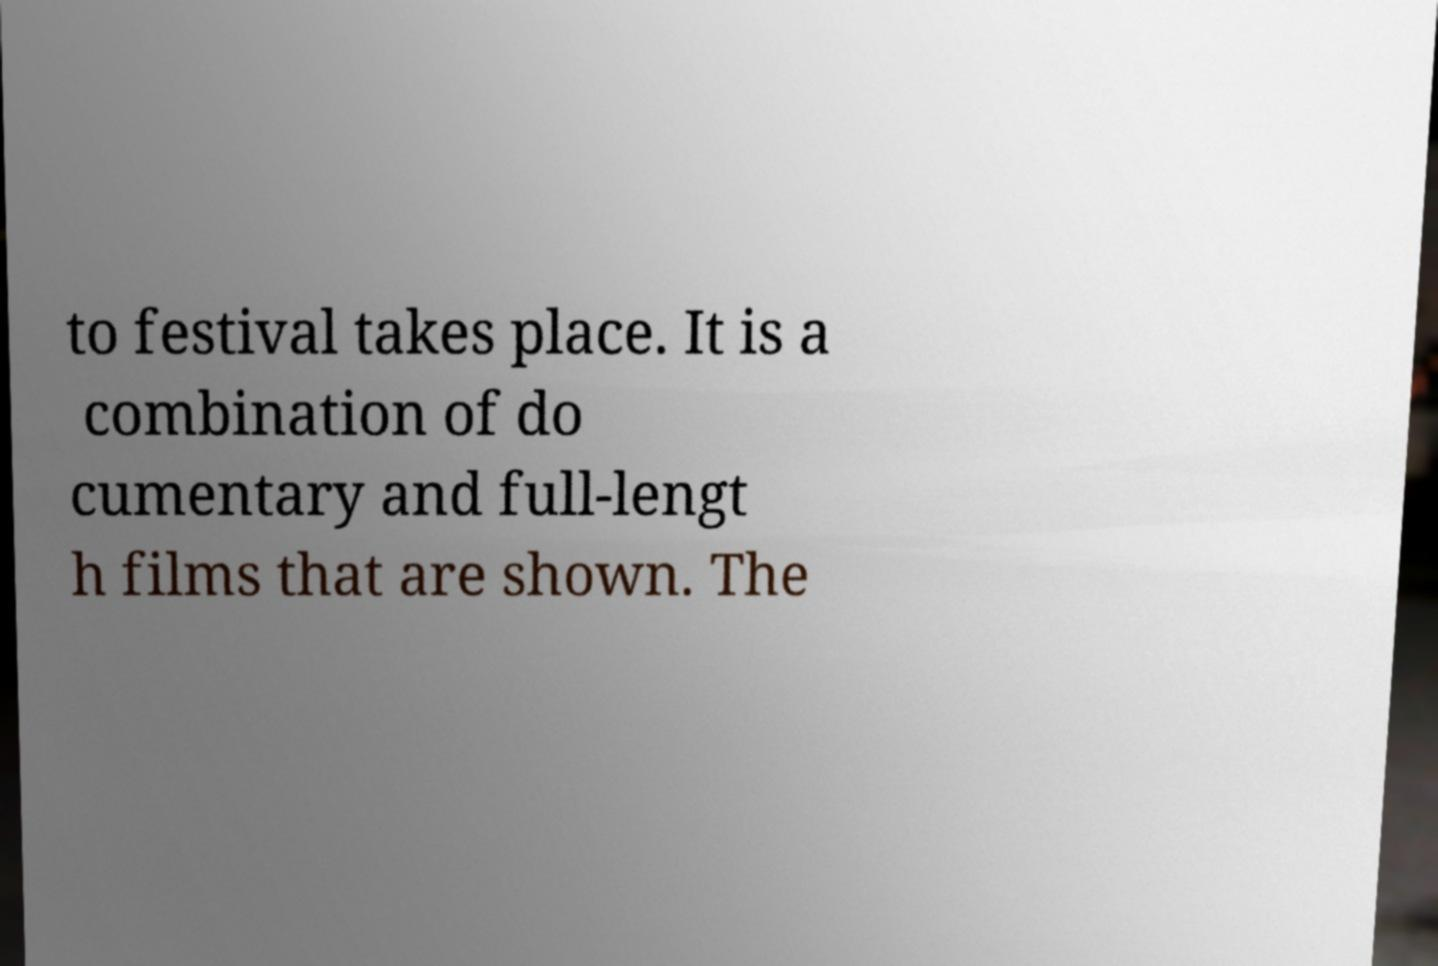Please identify and transcribe the text found in this image. to festival takes place. It is a combination of do cumentary and full-lengt h films that are shown. The 